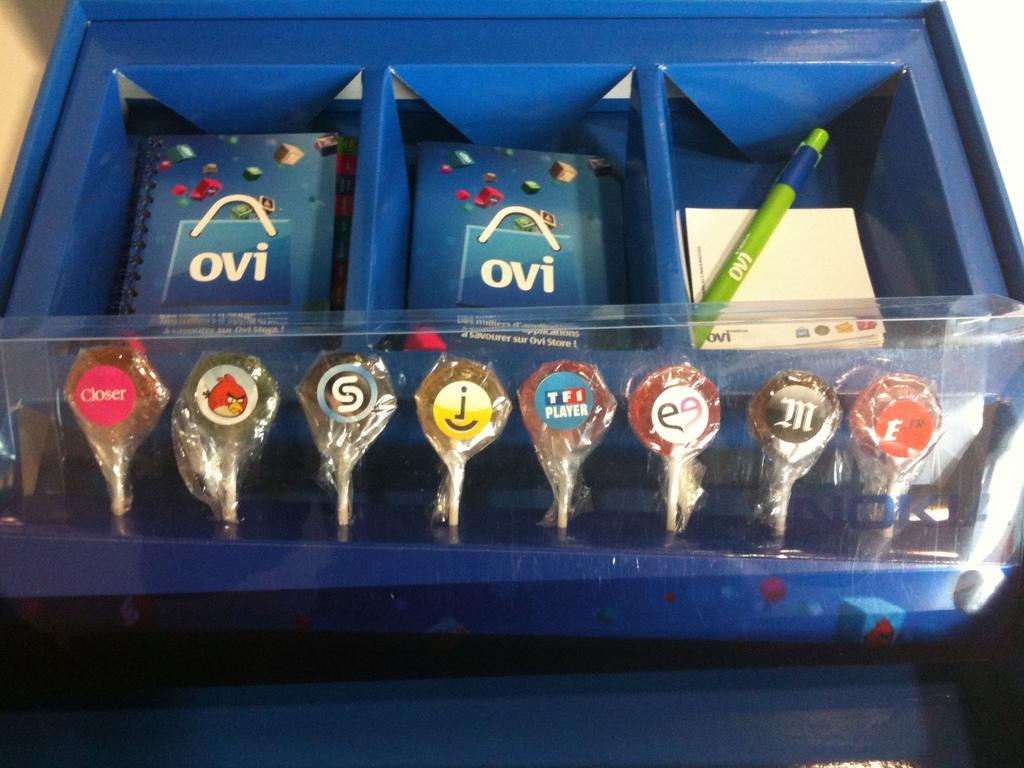What text is on the blue book?
Offer a terse response. Ovi. What word is on the far left lollipop?
Provide a short and direct response. Closer. 